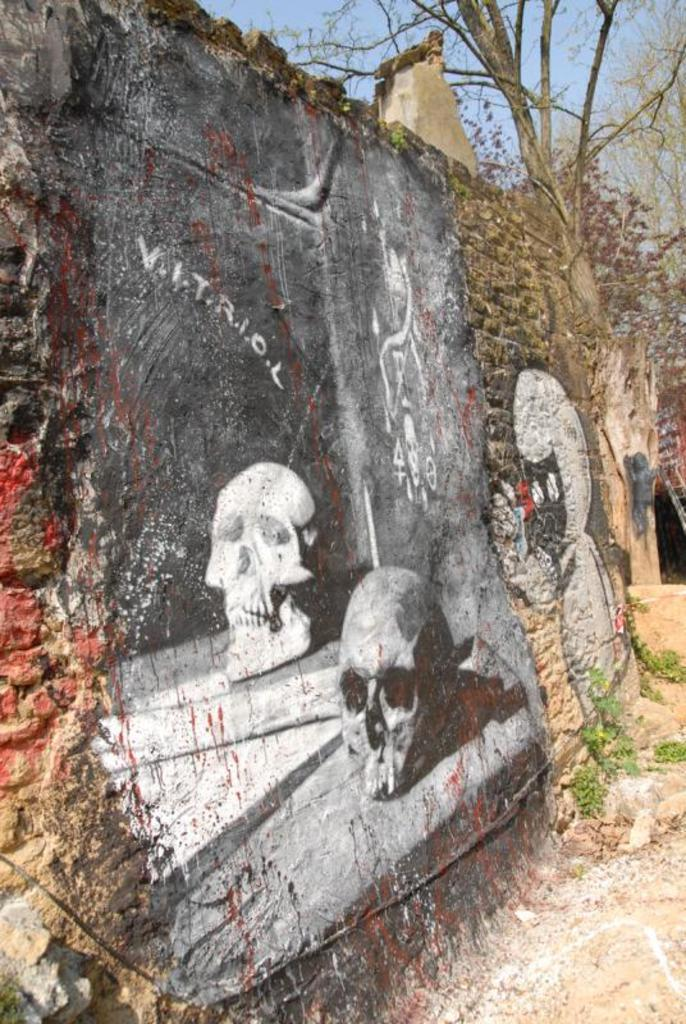What can be seen on the wall in the foreground of the image? There are paintings on the wall in the foreground of the image. What is located on the right side of the image? There are plants on the right side of the image. What is visible at the top of the image? Trees and the sky are visible at the top of the image. What type of mint is growing in the image? There is no mint present in the image. What fictional character can be seen in the paintings on the wall? The paintings on the wall do not depict any fictional characters; they are not described in the provided facts. 